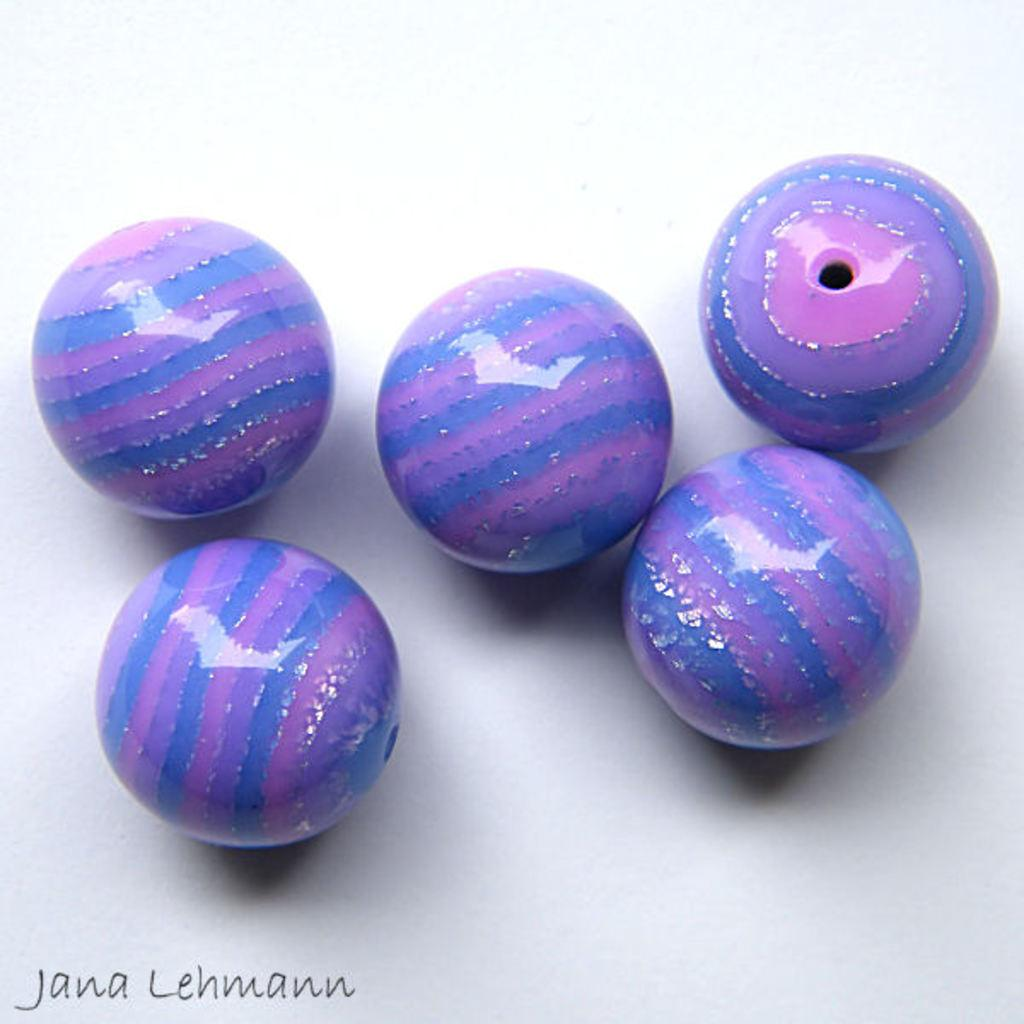What objects are present in the image? There are glass balls in the image. Where are the glass balls located? The glass balls are placed on a surface. What type of coat is being worn by the trucks in the image? There are no trucks or coats present in the image; it only features glass balls placed on a surface. 